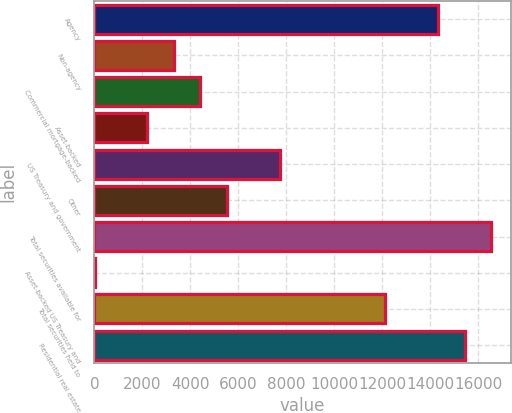Convert chart. <chart><loc_0><loc_0><loc_500><loc_500><bar_chart><fcel>Agency<fcel>Non-agency<fcel>Commercial mortgage-backed<fcel>Asset-backed<fcel>US Treasury and government<fcel>Other<fcel>Total securities available for<fcel>Asset-backed US Treasury and<fcel>Total securities held to<fcel>Residential real estate<nl><fcel>14334.7<fcel>3315.7<fcel>4417.6<fcel>2213.8<fcel>7723.3<fcel>5519.5<fcel>16538.5<fcel>10<fcel>12130.9<fcel>15436.6<nl></chart> 